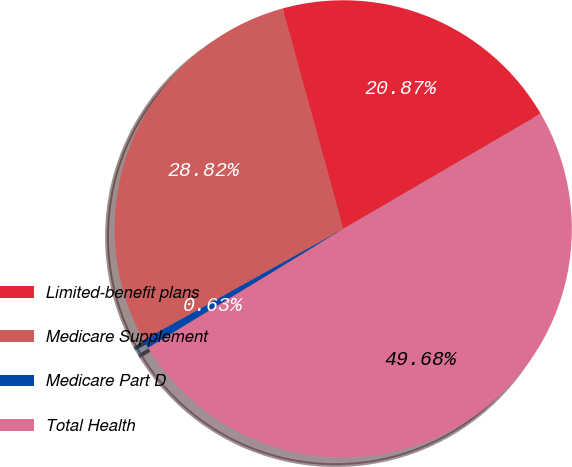<chart> <loc_0><loc_0><loc_500><loc_500><pie_chart><fcel>Limited-benefit plans<fcel>Medicare Supplement<fcel>Medicare Part D<fcel>Total Health<nl><fcel>20.87%<fcel>28.82%<fcel>0.63%<fcel>49.68%<nl></chart> 